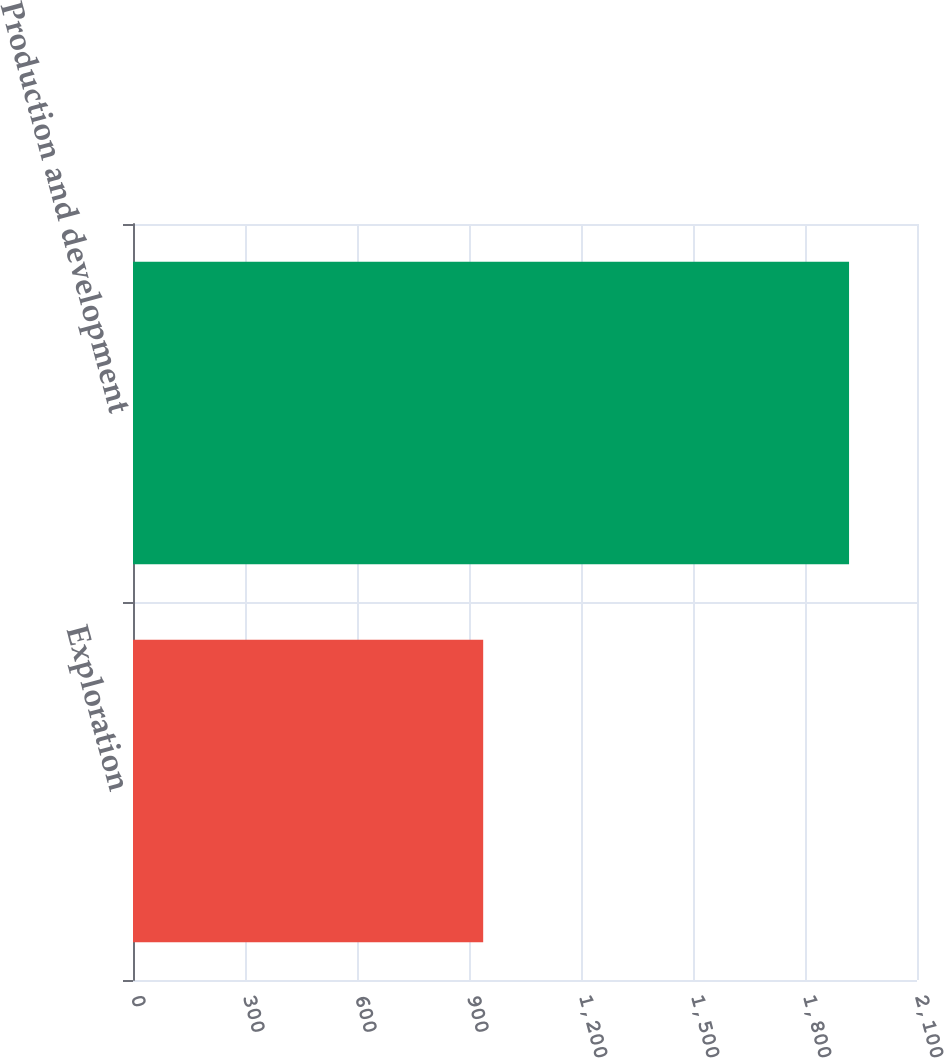Convert chart. <chart><loc_0><loc_0><loc_500><loc_500><bar_chart><fcel>Exploration<fcel>Production and development<nl><fcel>938<fcel>1918<nl></chart> 